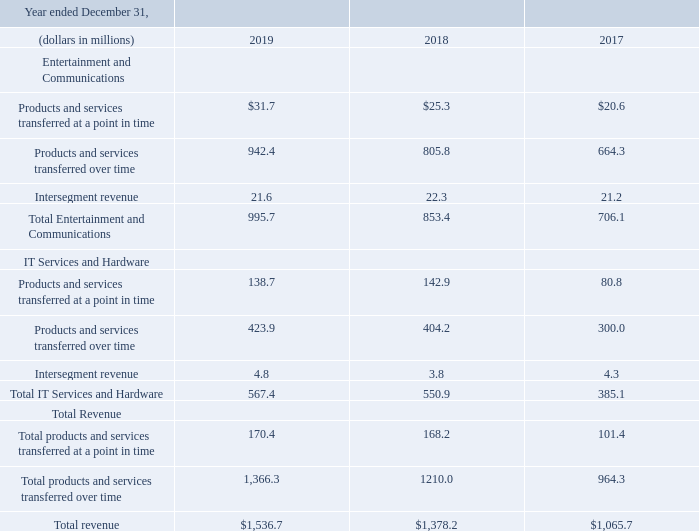In the first quarter of 2019, the Company determined that certain revenue in the IT Services and Hardware segment associated with nonrecurring projects is better aligned with Infrastructure Solutions, rather than Consulting, where it was previously reported.  As a result, the Company reclassed revenue of $26.6 million and $12.3 million from Consulting to Infrastructure Solutions for the twelve months ended December 31, 2018 and 2017, respectively.  This reclassification of revenue had no impact on the Consolidated Statements of Operations
The following table presents revenues disaggregated by contract type
What is the reclassified amount made by the company from  Consulting to Infrastructure Solutions for the twelve months ended December 31, 2018?
Answer scale should be: million. $26.6. What is the reclassified amount made by the company from  Consulting to Infrastructure Solutions for the twelve months ended December 31, 2019?
Answer scale should be: million. $12.3. What is the revenue from total entertainment and communications in 2019?
Answer scale should be: million. 995.7. What is the total revenue between 2017 to 2019?
Answer scale should be: million. 1,536.7+1,378.2+1,065.7
Answer: 3980.6. What is the total IT services and hardware between 2017 to 2019?
Answer scale should be: million. 567.4+550.9+385.1
Answer: 1503.4. What proportion of the 2019 total revenue is earned from total IT services and hardware?
Answer scale should be: percent. 567.4/1,536.7
Answer: 36.92. 